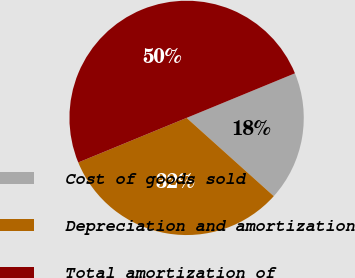<chart> <loc_0><loc_0><loc_500><loc_500><pie_chart><fcel>Cost of goods sold<fcel>Depreciation and amortization<fcel>Total amortization of<nl><fcel>17.86%<fcel>32.14%<fcel>50.0%<nl></chart> 